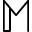Convert formula to latex. <formula><loc_0><loc_0><loc_500><loc_500>\mathbb { M }</formula> 